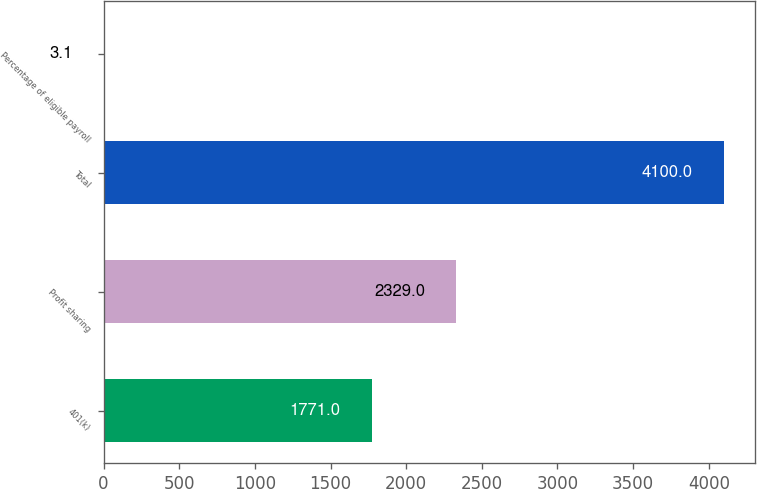Convert chart to OTSL. <chart><loc_0><loc_0><loc_500><loc_500><bar_chart><fcel>401(k)<fcel>Profit sharing<fcel>Total<fcel>Percentage of eligible payroll<nl><fcel>1771<fcel>2329<fcel>4100<fcel>3.1<nl></chart> 